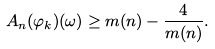Convert formula to latex. <formula><loc_0><loc_0><loc_500><loc_500>A _ { n } ( \varphi _ { k } ) ( \omega ) \geq m ( n ) - \frac { 4 } { m ( n ) } .</formula> 